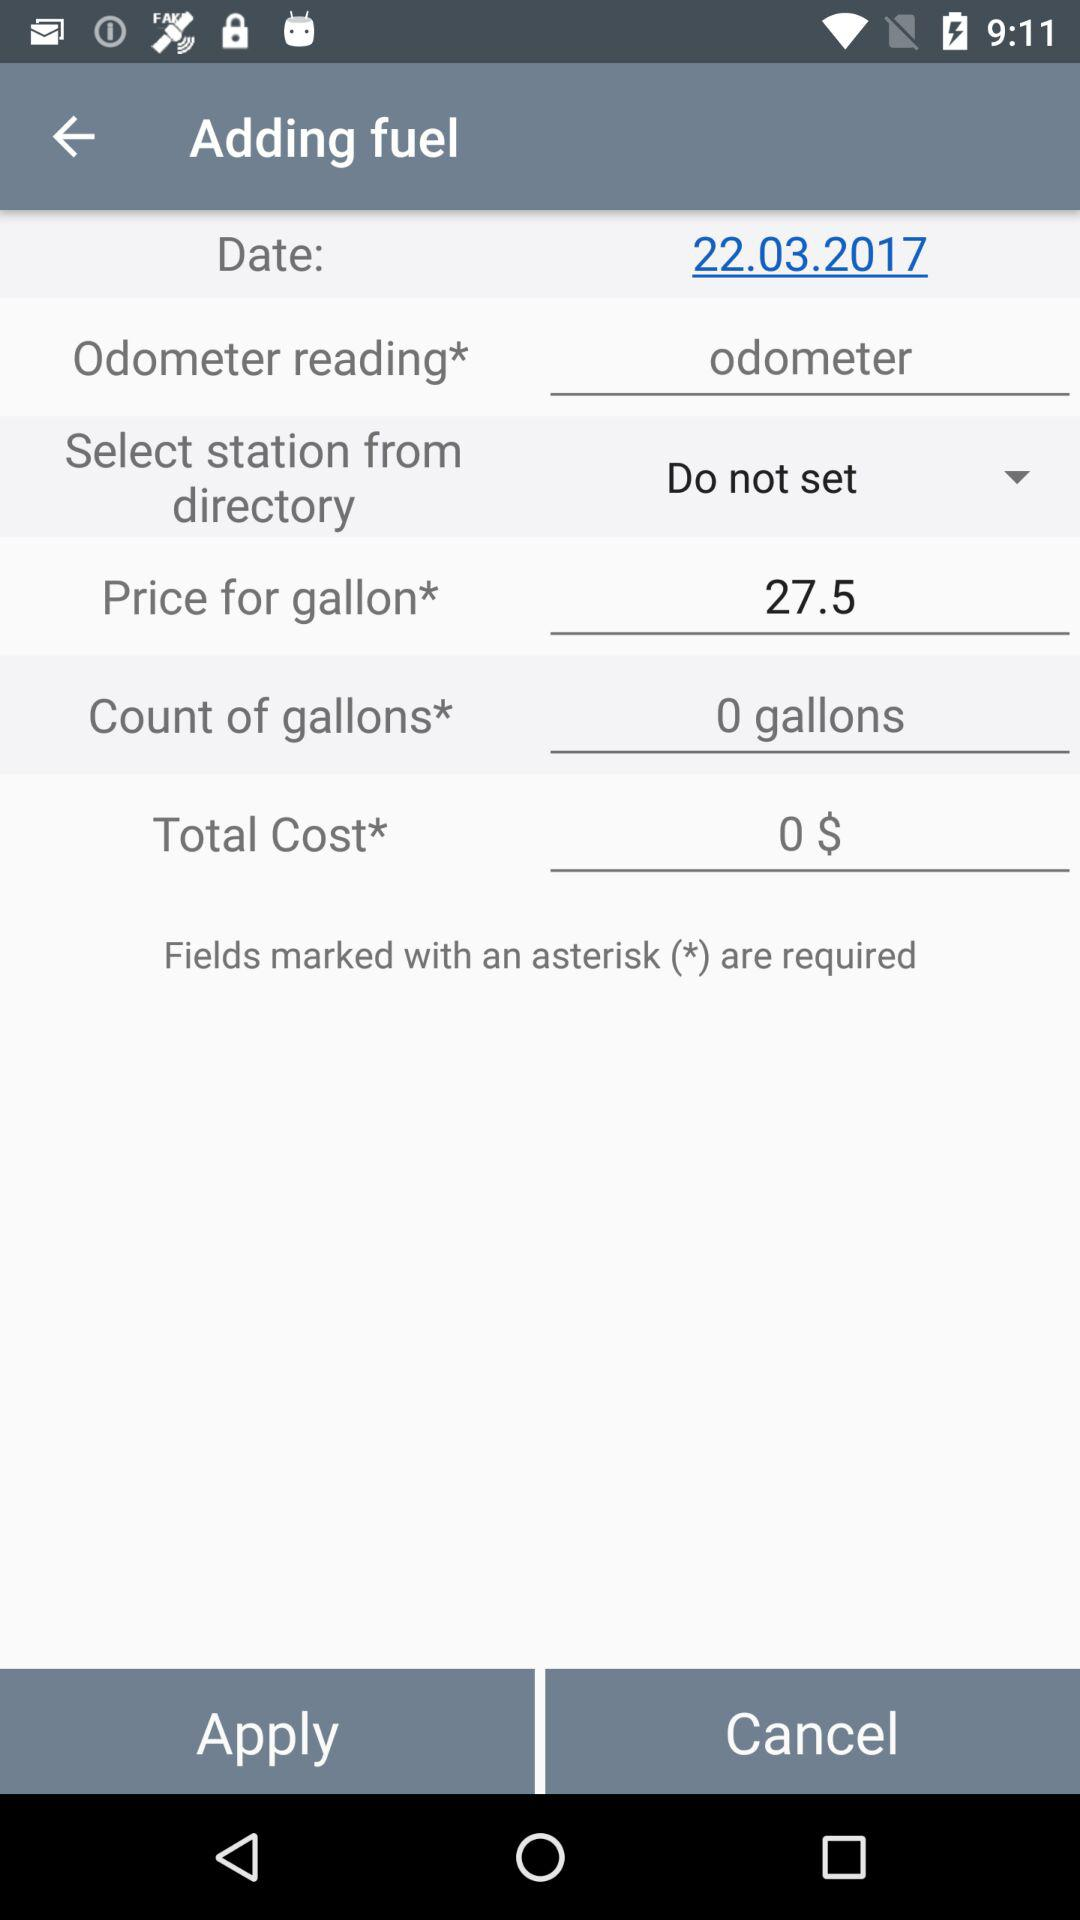What is the price per gallon? The price per gallon is 27.5. 